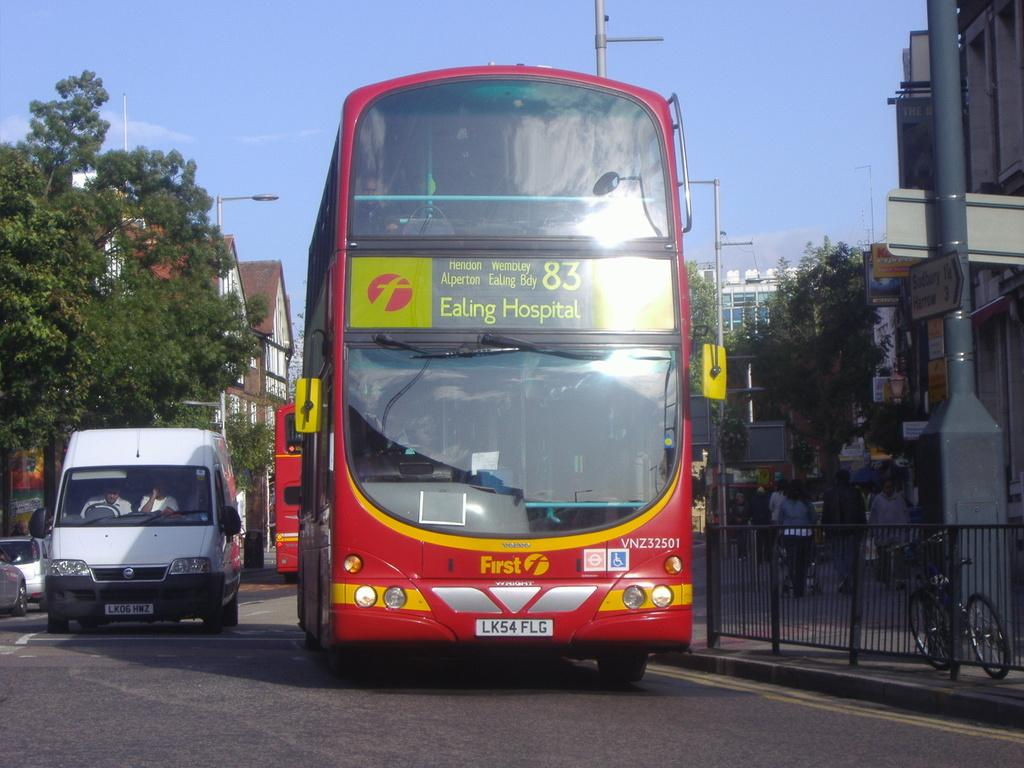<image>
Share a concise interpretation of the image provided. A red double-deck bus is driving down the road, headed to Ealing Hospital. 